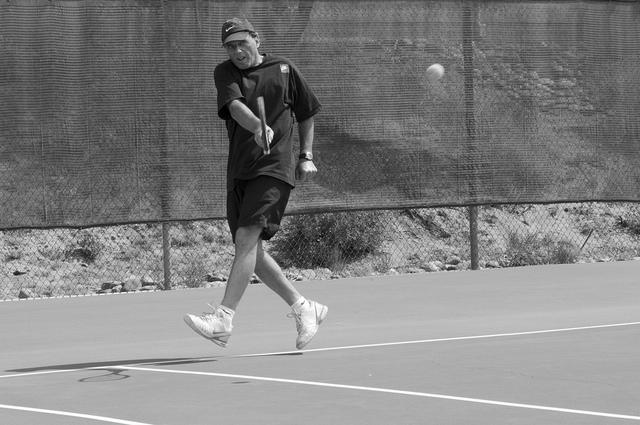Are the man's feet touching the ground?
Answer briefly. No. What sport is the man playing?
Be succinct. Tennis. What is the man holding in his hand?
Quick response, please. Tennis racket. 